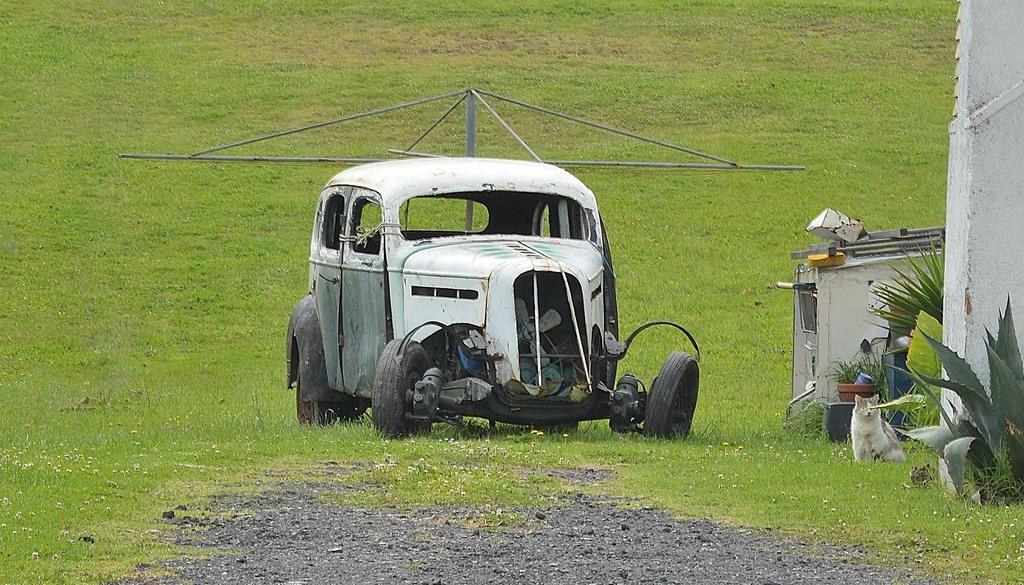What type of vehicle is in the image? There is an old car in the image. What can be seen in the background of the image? There is grass visible in the image. Can you describe any animals present in the image? Yes, there is a cat on the right side of the image. What type of cloth is the lawyer using to cover the corn in the image? There is no lawyer, cloth, or corn present in the image. 